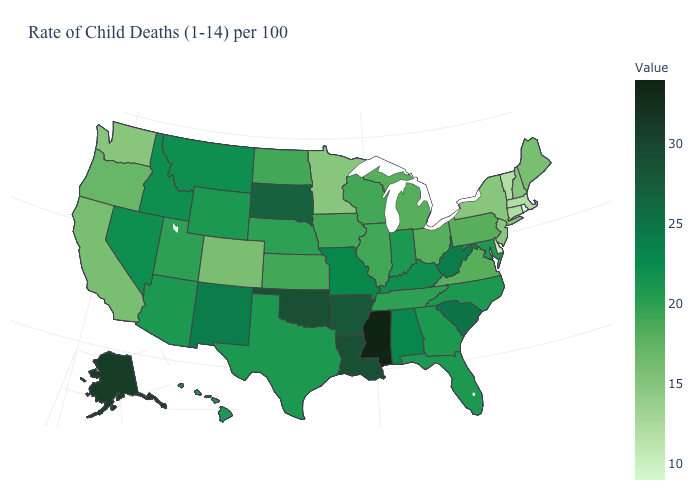Is the legend a continuous bar?
Keep it brief. Yes. Is the legend a continuous bar?
Give a very brief answer. Yes. Which states have the lowest value in the USA?
Write a very short answer. Rhode Island. Among the states that border West Virginia , does Ohio have the highest value?
Answer briefly. No. Which states hav the highest value in the West?
Quick response, please. Alaska. Does Rhode Island have the lowest value in the Northeast?
Write a very short answer. Yes. 